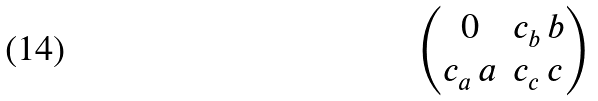<formula> <loc_0><loc_0><loc_500><loc_500>\begin{pmatrix} 0 & c _ { b } \, b \\ c _ { a } \, a & c _ { c } \, c \end{pmatrix}</formula> 